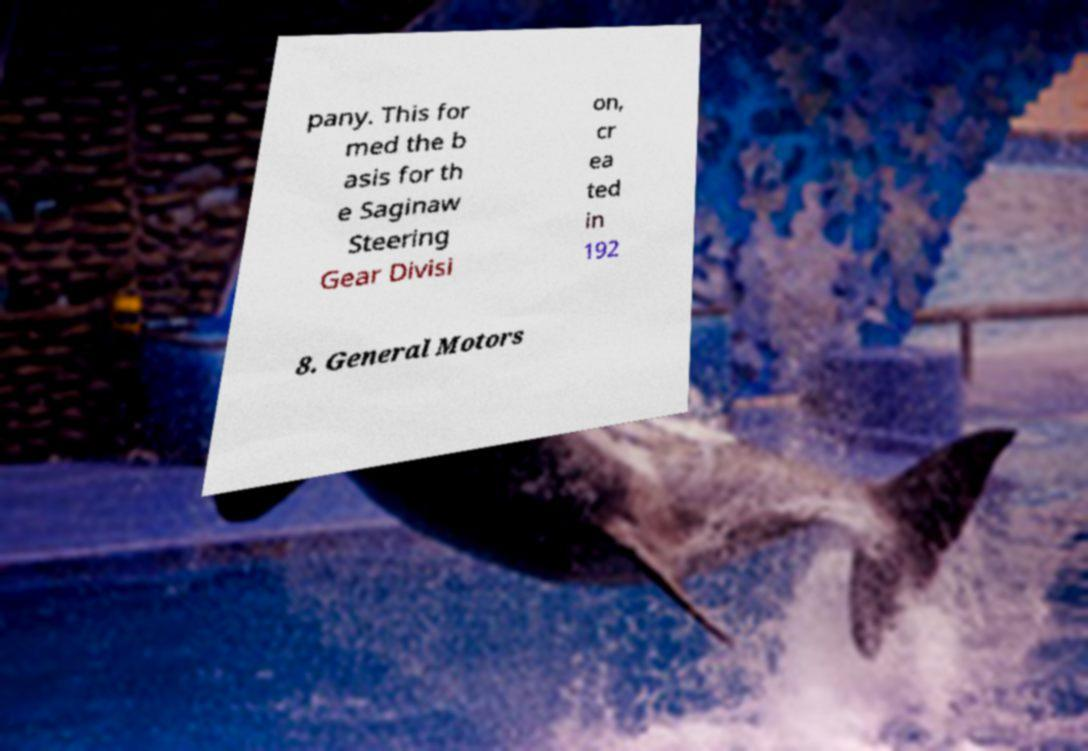Please identify and transcribe the text found in this image. pany. This for med the b asis for th e Saginaw Steering Gear Divisi on, cr ea ted in 192 8. General Motors 